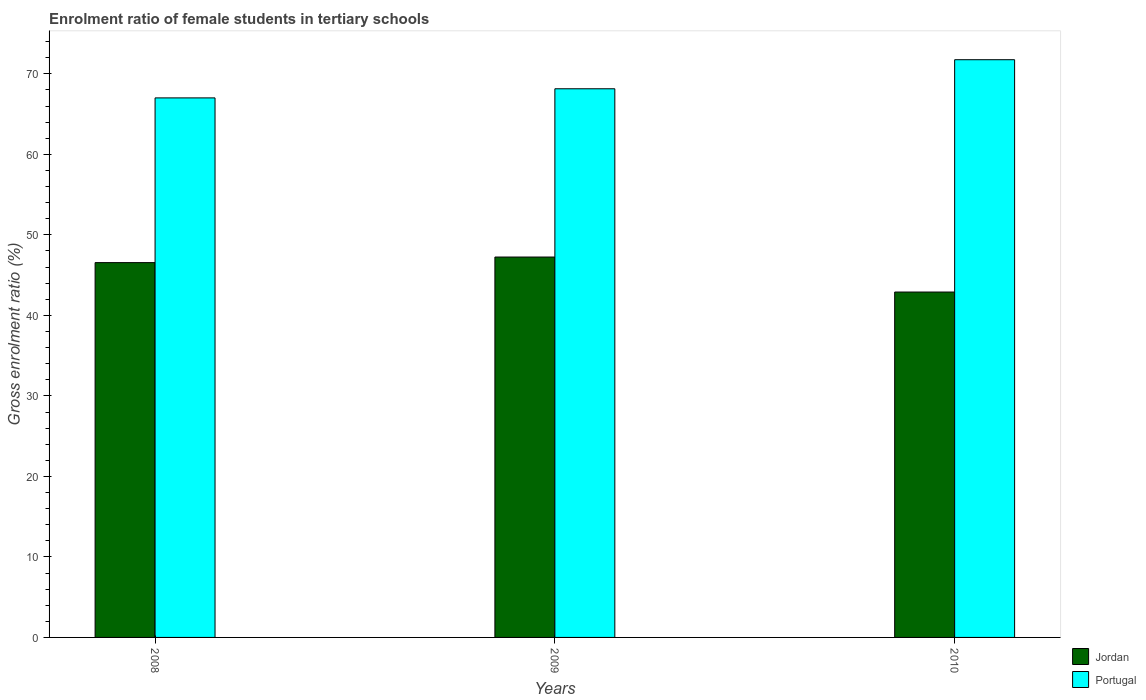How many different coloured bars are there?
Keep it short and to the point. 2. Are the number of bars per tick equal to the number of legend labels?
Your response must be concise. Yes. How many bars are there on the 3rd tick from the left?
Your response must be concise. 2. What is the label of the 2nd group of bars from the left?
Offer a very short reply. 2009. In how many cases, is the number of bars for a given year not equal to the number of legend labels?
Provide a succinct answer. 0. What is the enrolment ratio of female students in tertiary schools in Portugal in 2009?
Offer a terse response. 68.15. Across all years, what is the maximum enrolment ratio of female students in tertiary schools in Jordan?
Provide a short and direct response. 47.25. Across all years, what is the minimum enrolment ratio of female students in tertiary schools in Jordan?
Keep it short and to the point. 42.9. In which year was the enrolment ratio of female students in tertiary schools in Portugal maximum?
Your answer should be very brief. 2010. What is the total enrolment ratio of female students in tertiary schools in Jordan in the graph?
Your response must be concise. 136.71. What is the difference between the enrolment ratio of female students in tertiary schools in Portugal in 2008 and that in 2009?
Provide a short and direct response. -1.13. What is the difference between the enrolment ratio of female students in tertiary schools in Jordan in 2008 and the enrolment ratio of female students in tertiary schools in Portugal in 2010?
Your response must be concise. -25.2. What is the average enrolment ratio of female students in tertiary schools in Jordan per year?
Ensure brevity in your answer.  45.57. In the year 2010, what is the difference between the enrolment ratio of female students in tertiary schools in Jordan and enrolment ratio of female students in tertiary schools in Portugal?
Give a very brief answer. -28.86. In how many years, is the enrolment ratio of female students in tertiary schools in Jordan greater than 12 %?
Offer a very short reply. 3. What is the ratio of the enrolment ratio of female students in tertiary schools in Jordan in 2008 to that in 2010?
Keep it short and to the point. 1.09. Is the difference between the enrolment ratio of female students in tertiary schools in Jordan in 2008 and 2010 greater than the difference between the enrolment ratio of female students in tertiary schools in Portugal in 2008 and 2010?
Offer a terse response. Yes. What is the difference between the highest and the second highest enrolment ratio of female students in tertiary schools in Portugal?
Offer a very short reply. 3.61. What is the difference between the highest and the lowest enrolment ratio of female students in tertiary schools in Portugal?
Give a very brief answer. 4.74. Is the sum of the enrolment ratio of female students in tertiary schools in Jordan in 2008 and 2010 greater than the maximum enrolment ratio of female students in tertiary schools in Portugal across all years?
Provide a succinct answer. Yes. What does the 1st bar from the left in 2008 represents?
Offer a very short reply. Jordan. What does the 2nd bar from the right in 2009 represents?
Keep it short and to the point. Jordan. How many bars are there?
Provide a succinct answer. 6. Are all the bars in the graph horizontal?
Provide a succinct answer. No. Where does the legend appear in the graph?
Keep it short and to the point. Bottom right. How many legend labels are there?
Provide a short and direct response. 2. How are the legend labels stacked?
Offer a terse response. Vertical. What is the title of the graph?
Your response must be concise. Enrolment ratio of female students in tertiary schools. Does "Montenegro" appear as one of the legend labels in the graph?
Your answer should be very brief. No. What is the label or title of the X-axis?
Ensure brevity in your answer.  Years. What is the label or title of the Y-axis?
Offer a terse response. Gross enrolment ratio (%). What is the Gross enrolment ratio (%) in Jordan in 2008?
Your response must be concise. 46.56. What is the Gross enrolment ratio (%) in Portugal in 2008?
Your answer should be very brief. 67.02. What is the Gross enrolment ratio (%) of Jordan in 2009?
Your answer should be very brief. 47.25. What is the Gross enrolment ratio (%) of Portugal in 2009?
Offer a very short reply. 68.15. What is the Gross enrolment ratio (%) in Jordan in 2010?
Make the answer very short. 42.9. What is the Gross enrolment ratio (%) of Portugal in 2010?
Offer a terse response. 71.76. Across all years, what is the maximum Gross enrolment ratio (%) in Jordan?
Your response must be concise. 47.25. Across all years, what is the maximum Gross enrolment ratio (%) in Portugal?
Give a very brief answer. 71.76. Across all years, what is the minimum Gross enrolment ratio (%) in Jordan?
Offer a terse response. 42.9. Across all years, what is the minimum Gross enrolment ratio (%) of Portugal?
Provide a short and direct response. 67.02. What is the total Gross enrolment ratio (%) of Jordan in the graph?
Your answer should be compact. 136.71. What is the total Gross enrolment ratio (%) in Portugal in the graph?
Your answer should be compact. 206.93. What is the difference between the Gross enrolment ratio (%) of Jordan in 2008 and that in 2009?
Your response must be concise. -0.69. What is the difference between the Gross enrolment ratio (%) in Portugal in 2008 and that in 2009?
Provide a short and direct response. -1.13. What is the difference between the Gross enrolment ratio (%) in Jordan in 2008 and that in 2010?
Your answer should be compact. 3.66. What is the difference between the Gross enrolment ratio (%) of Portugal in 2008 and that in 2010?
Offer a terse response. -4.74. What is the difference between the Gross enrolment ratio (%) in Jordan in 2009 and that in 2010?
Provide a succinct answer. 4.35. What is the difference between the Gross enrolment ratio (%) in Portugal in 2009 and that in 2010?
Offer a very short reply. -3.61. What is the difference between the Gross enrolment ratio (%) of Jordan in 2008 and the Gross enrolment ratio (%) of Portugal in 2009?
Give a very brief answer. -21.59. What is the difference between the Gross enrolment ratio (%) of Jordan in 2008 and the Gross enrolment ratio (%) of Portugal in 2010?
Your answer should be compact. -25.2. What is the difference between the Gross enrolment ratio (%) of Jordan in 2009 and the Gross enrolment ratio (%) of Portugal in 2010?
Your answer should be very brief. -24.51. What is the average Gross enrolment ratio (%) of Jordan per year?
Provide a short and direct response. 45.57. What is the average Gross enrolment ratio (%) of Portugal per year?
Ensure brevity in your answer.  68.98. In the year 2008, what is the difference between the Gross enrolment ratio (%) of Jordan and Gross enrolment ratio (%) of Portugal?
Make the answer very short. -20.46. In the year 2009, what is the difference between the Gross enrolment ratio (%) in Jordan and Gross enrolment ratio (%) in Portugal?
Your answer should be compact. -20.9. In the year 2010, what is the difference between the Gross enrolment ratio (%) of Jordan and Gross enrolment ratio (%) of Portugal?
Make the answer very short. -28.86. What is the ratio of the Gross enrolment ratio (%) in Jordan in 2008 to that in 2009?
Your answer should be compact. 0.99. What is the ratio of the Gross enrolment ratio (%) of Portugal in 2008 to that in 2009?
Offer a very short reply. 0.98. What is the ratio of the Gross enrolment ratio (%) in Jordan in 2008 to that in 2010?
Offer a very short reply. 1.09. What is the ratio of the Gross enrolment ratio (%) of Portugal in 2008 to that in 2010?
Offer a very short reply. 0.93. What is the ratio of the Gross enrolment ratio (%) in Jordan in 2009 to that in 2010?
Keep it short and to the point. 1.1. What is the ratio of the Gross enrolment ratio (%) of Portugal in 2009 to that in 2010?
Keep it short and to the point. 0.95. What is the difference between the highest and the second highest Gross enrolment ratio (%) of Jordan?
Keep it short and to the point. 0.69. What is the difference between the highest and the second highest Gross enrolment ratio (%) in Portugal?
Your answer should be compact. 3.61. What is the difference between the highest and the lowest Gross enrolment ratio (%) of Jordan?
Provide a short and direct response. 4.35. What is the difference between the highest and the lowest Gross enrolment ratio (%) of Portugal?
Make the answer very short. 4.74. 